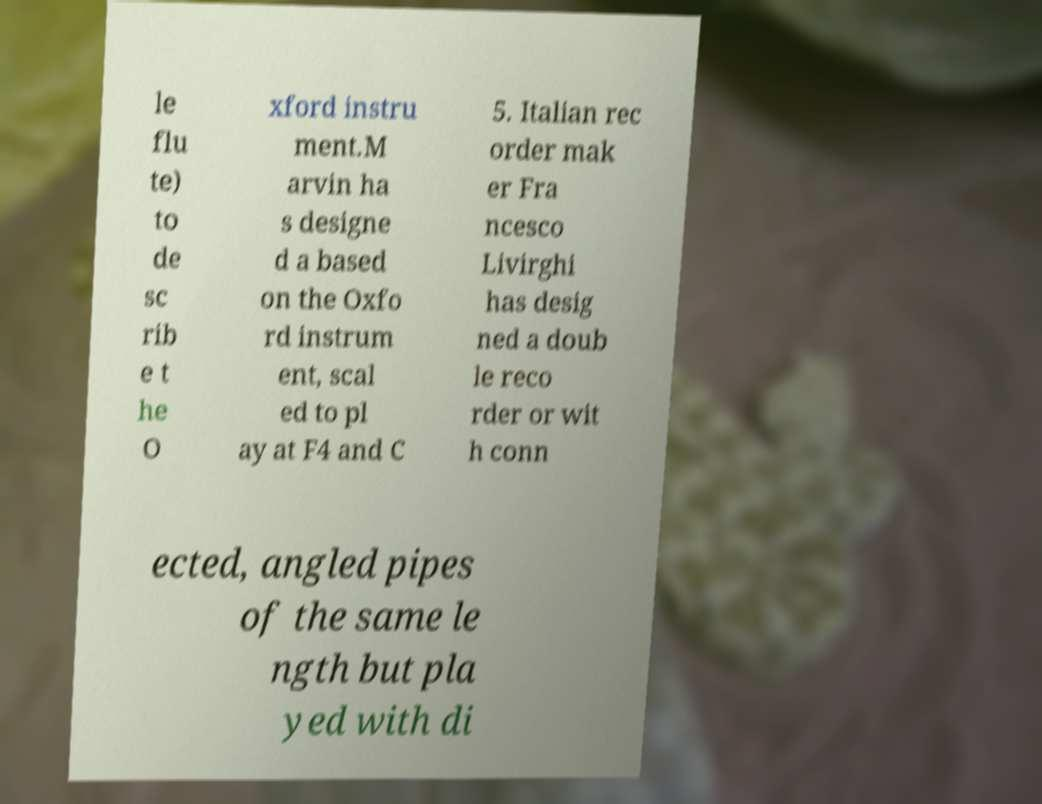I need the written content from this picture converted into text. Can you do that? le flu te) to de sc rib e t he O xford instru ment.M arvin ha s designe d a based on the Oxfo rd instrum ent, scal ed to pl ay at F4 and C 5. Italian rec order mak er Fra ncesco Livirghi has desig ned a doub le reco rder or wit h conn ected, angled pipes of the same le ngth but pla yed with di 